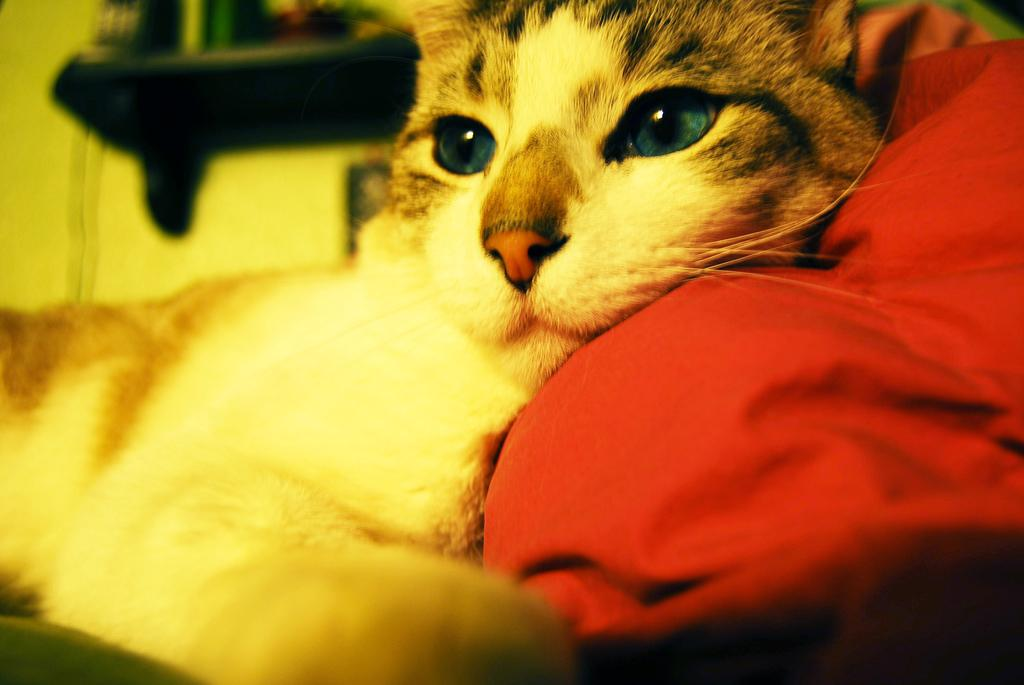What is the main subject in the foreground of the image? There is a cat in the foreground of the image. What is the cat doing in the image? The cat is sleeping on a red color cloth. What can be seen in the background of the image? There is a shelf in the background of the image. How is the shelf positioned in the image? The shelf is attached to a wall. What is on the shelf in the image? There are objects placed on the shelf. What type of effect does the cat's wing have on the red color cloth in the image? There is no mention of a wing in the image, as the cat is a cat and does not have wings. 